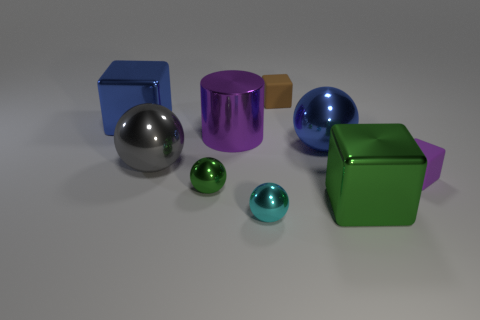Does the small ball that is on the left side of the cyan object have the same color as the big metallic sphere on the left side of the large purple metal cylinder?
Provide a succinct answer. No. What is the size of the object that is the same color as the large cylinder?
Offer a terse response. Small. Are there any large brown balls made of the same material as the green cube?
Your answer should be compact. No. Is the number of big green cubes that are on the right side of the purple matte thing the same as the number of blue metallic things right of the cyan thing?
Your answer should be very brief. No. How big is the block on the left side of the tiny cyan metallic thing?
Give a very brief answer. Large. What material is the block behind the big block that is on the left side of the gray sphere made of?
Make the answer very short. Rubber. There is a large cube right of the big blue shiny object behind the large shiny cylinder; what number of tiny brown blocks are left of it?
Your response must be concise. 1. Do the large block to the left of the cyan thing and the tiny sphere that is in front of the green cube have the same material?
Your answer should be compact. Yes. What is the material of the small thing that is the same color as the large metallic cylinder?
Give a very brief answer. Rubber. What number of gray metal things are the same shape as the large purple metal thing?
Make the answer very short. 0. 